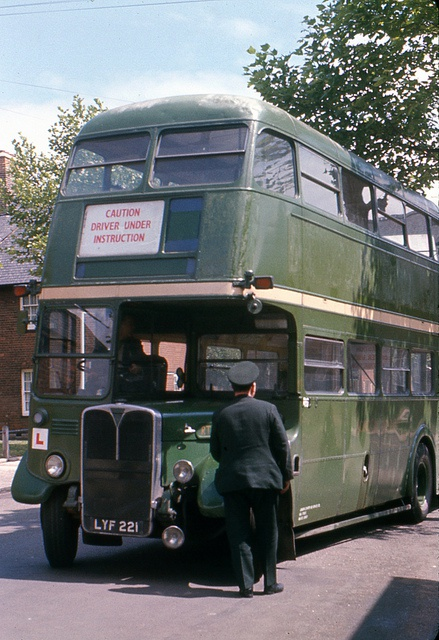Describe the objects in this image and their specific colors. I can see bus in lightblue, black, gray, darkgray, and blue tones and people in lightblue, black, gray, and darkblue tones in this image. 